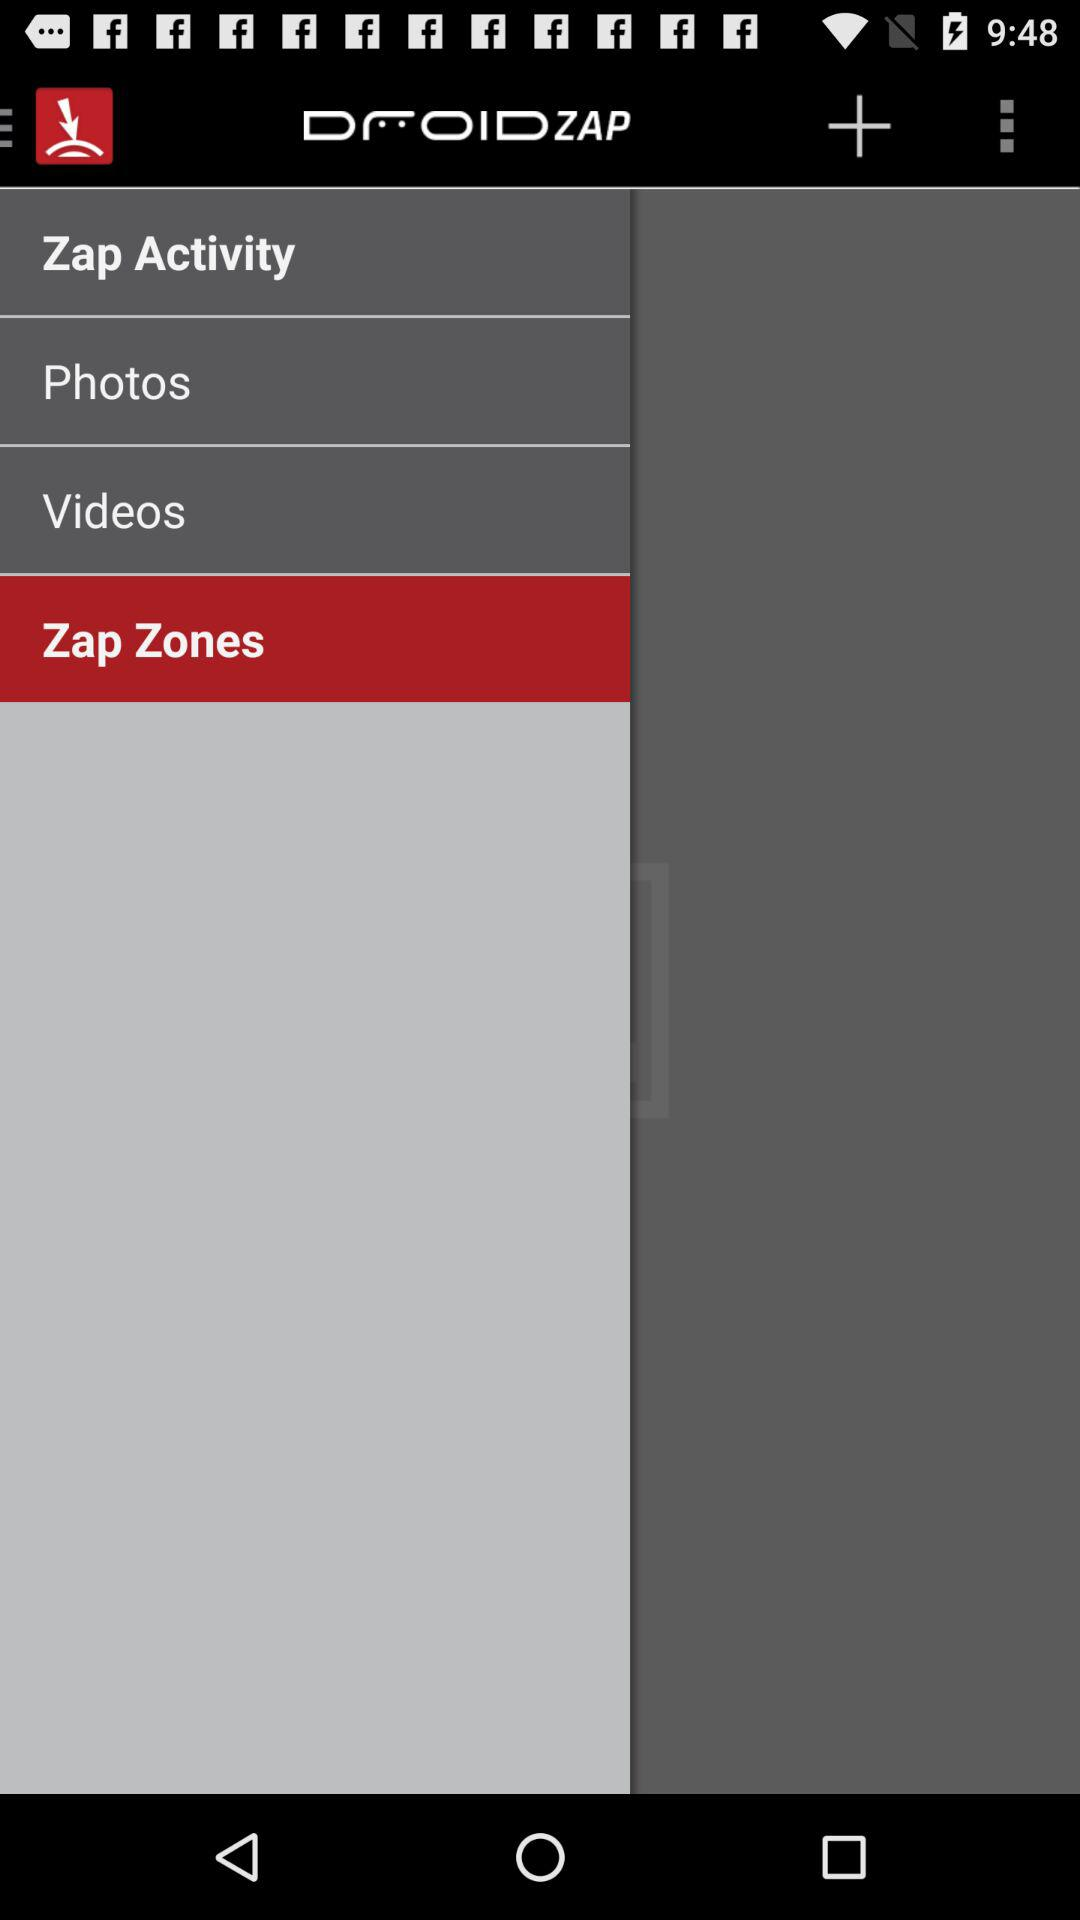Which item has been selected? The item that has been selected is "Zap Zones". 